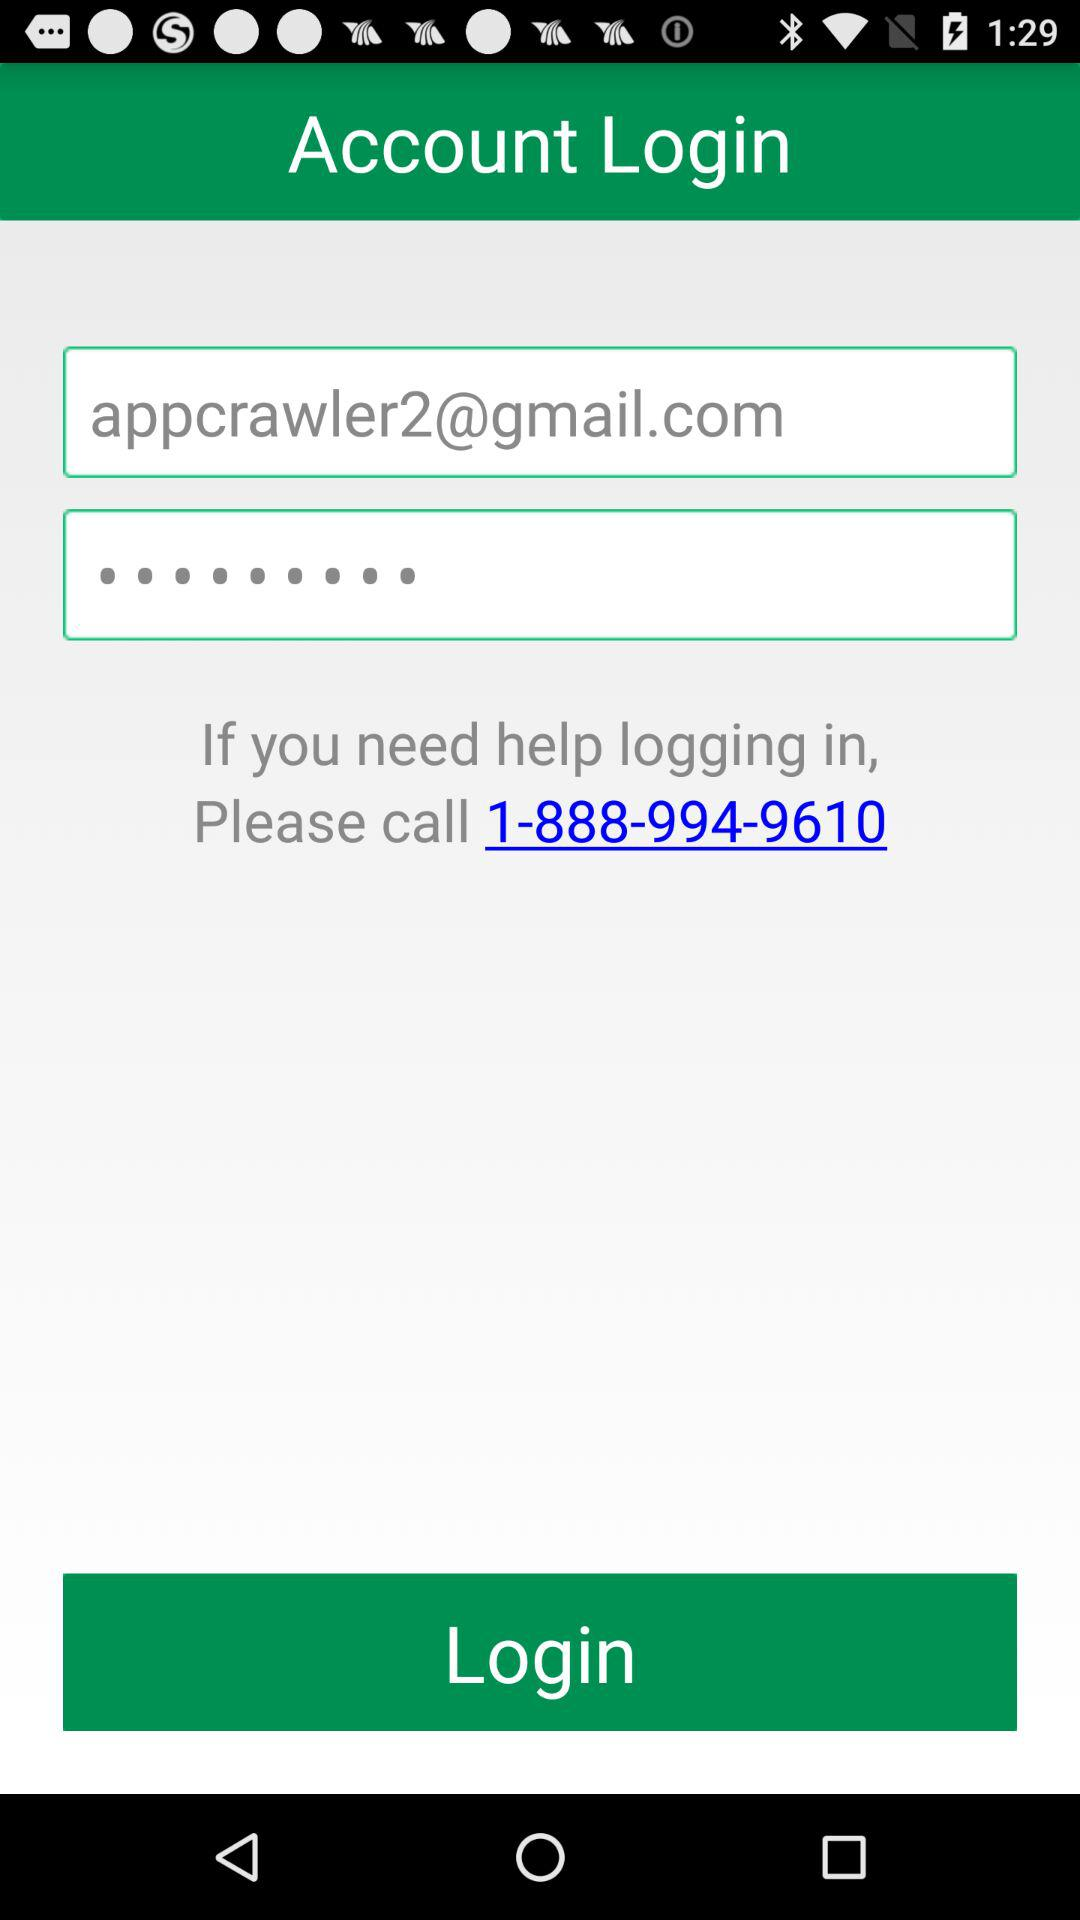How many text fields are there in the login form?
Answer the question using a single word or phrase. 2 